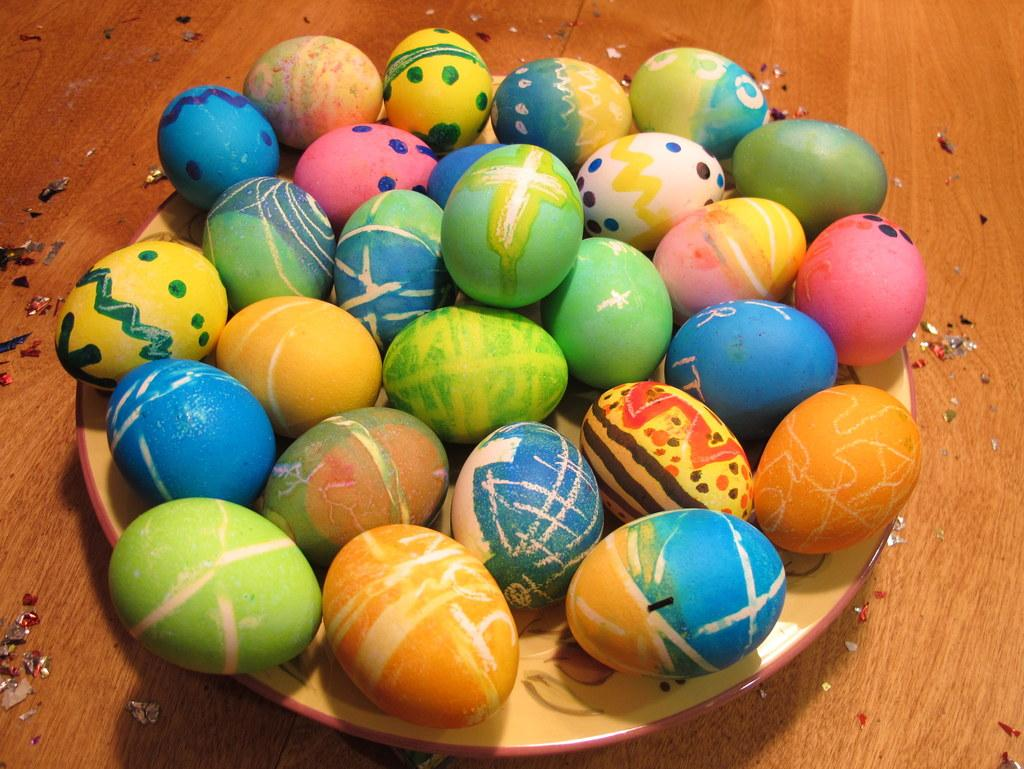What is present on the wooden surface in the image? There is a plate in the image. What is the plate resting on? The plate is on a wooden surface. What can be seen on the plate? There are different colors of eggs in the plate. How quiet is the wooden surface in the image? The wooden surface's quietness cannot be determined from the image, as it is an inanimate object and does not produce sound. 